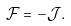<formula> <loc_0><loc_0><loc_500><loc_500>\mathcal { F } = - \mathcal { J } .</formula> 